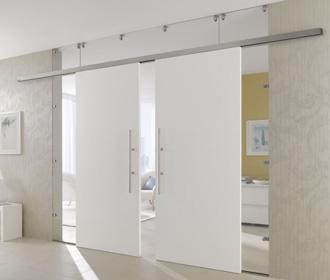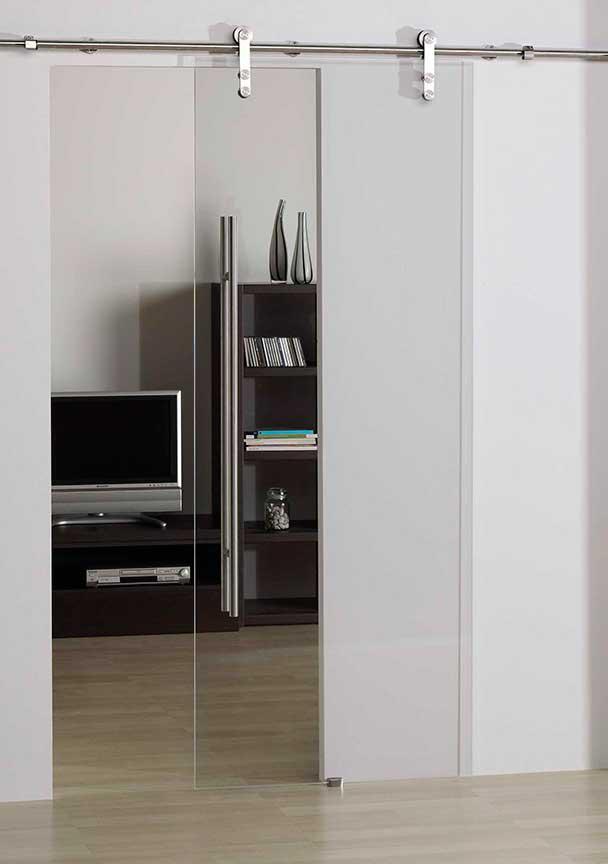The first image is the image on the left, the second image is the image on the right. Given the left and right images, does the statement "One set of sliding doors is white." hold true? Answer yes or no. Yes. 